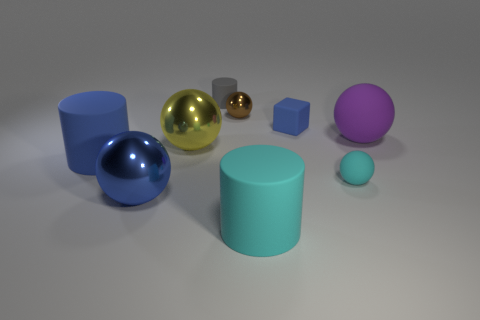How many other objects are there of the same color as the small cylinder?
Give a very brief answer. 0. Do the yellow shiny thing and the purple matte sphere have the same size?
Provide a succinct answer. Yes. How many things are gray things or blue matte things right of the small brown metallic object?
Ensure brevity in your answer.  2. Is the number of large matte balls that are on the left side of the large purple rubber ball less than the number of tiny blue matte objects that are to the left of the tiny block?
Offer a terse response. No. What number of other things are the same material as the gray cylinder?
Your response must be concise. 5. Does the large shiny ball right of the blue sphere have the same color as the small rubber block?
Make the answer very short. No. There is a tiny object that is right of the blue block; are there any tiny metallic objects that are on the right side of it?
Make the answer very short. No. What material is the cylinder that is both right of the large yellow shiny sphere and in front of the gray cylinder?
Offer a terse response. Rubber. What is the shape of the big yellow object that is the same material as the small brown thing?
Give a very brief answer. Sphere. Is there any other thing that is the same shape as the small metal thing?
Your answer should be compact. Yes. 